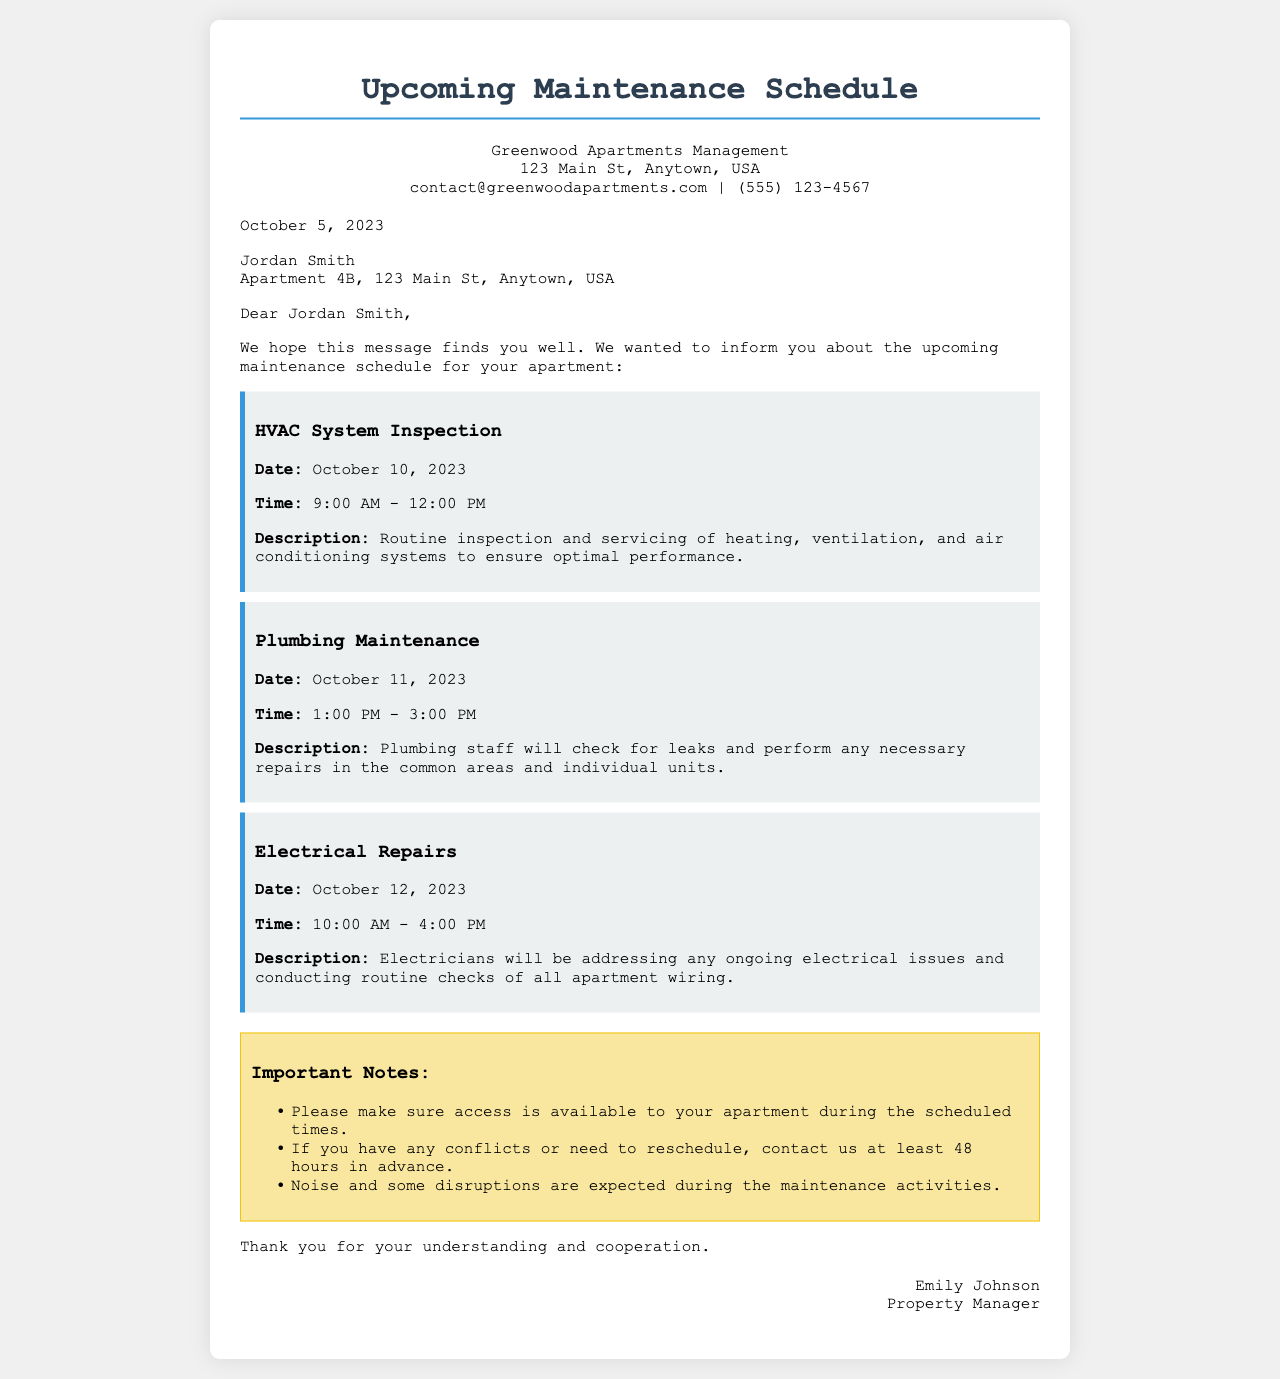What is the date of the HVAC system inspection? The HVAC system inspection is scheduled for October 10, 2023.
Answer: October 10, 2023 What time does the plumbing maintenance take place? The plumbing maintenance is scheduled from 1:00 PM to 3:00 PM.
Answer: 1:00 PM - 3:00 PM Who is the property manager? The property manager's name is Emily Johnson.
Answer: Emily Johnson What should residents expect during the maintenance? Residents should expect noise and some disruptions during the maintenance activities.
Answer: Noise and disruptions How far in advance should residents contact the management to reschedule? Residents need to contact management at least 48 hours in advance to reschedule.
Answer: 48 hours What is the description of the electrical repairs? The electrical repairs include addressing ongoing electrical issues and conducting routine checks of all apartment wiring.
Answer: Addressing ongoing electrical issues When is the plumbing maintenance scheduled? Plumbing maintenance is scheduled for October 11, 2023.
Answer: October 11, 2023 What is the address of Greenwood Apartments? The address is 123 Main St, Anytown, USA.
Answer: 123 Main St, Anytown, USA What can residents do if they have a conflict with the maintenance schedule? Residents should contact management to reschedule if they have a conflict.
Answer: Contact management to reschedule 